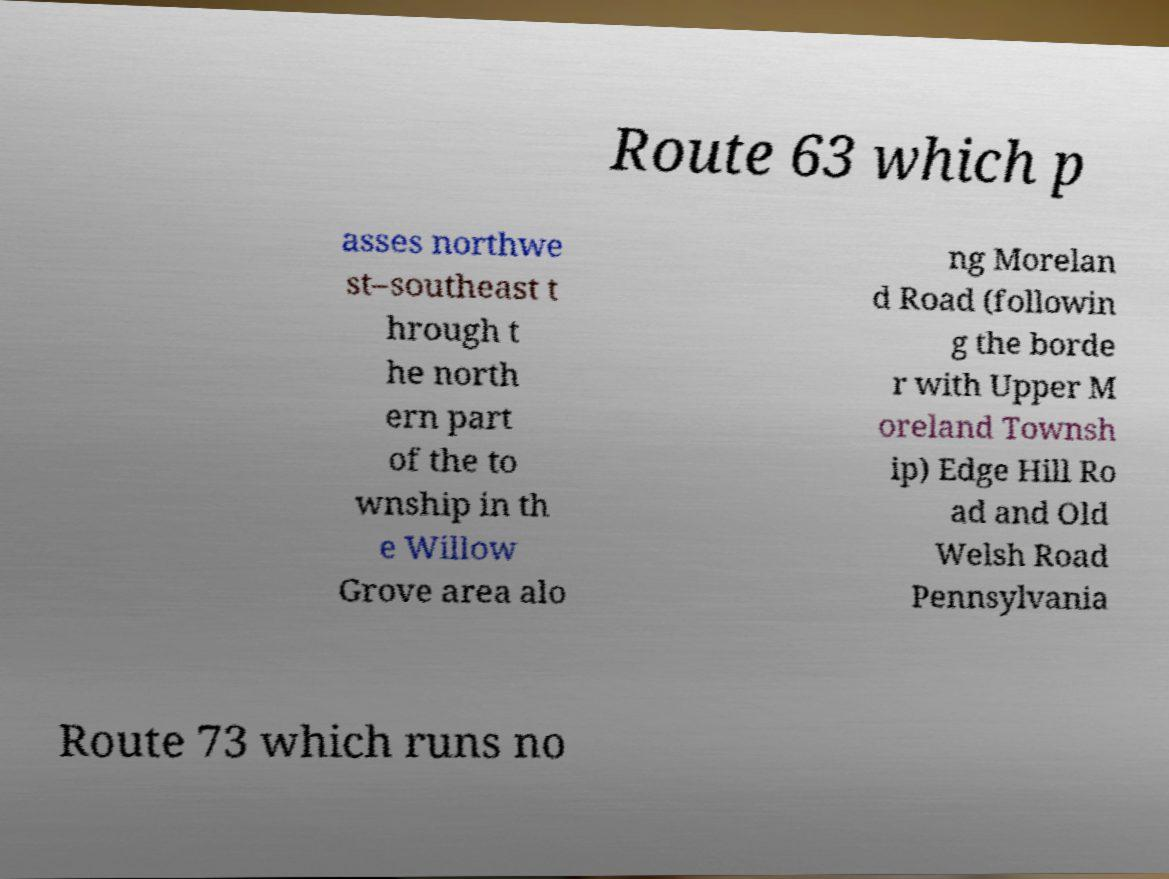Please read and relay the text visible in this image. What does it say? Route 63 which p asses northwe st–southeast t hrough t he north ern part of the to wnship in th e Willow Grove area alo ng Morelan d Road (followin g the borde r with Upper M oreland Townsh ip) Edge Hill Ro ad and Old Welsh Road Pennsylvania Route 73 which runs no 